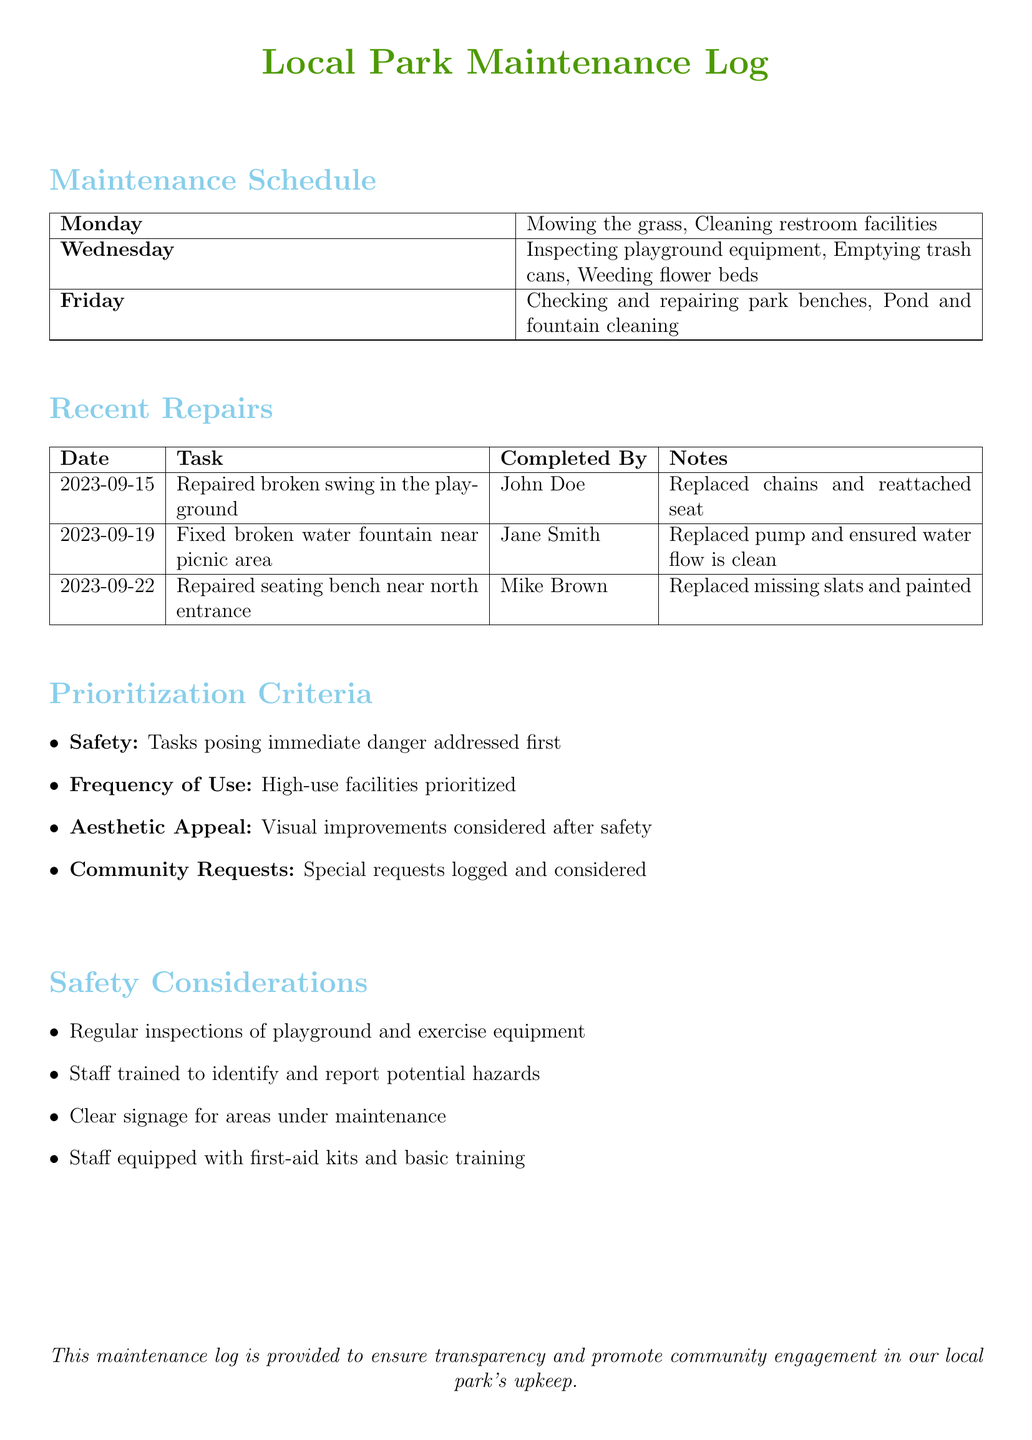What is the main task scheduled for Monday? The main tasks for Monday are mowing the grass and cleaning restroom facilities.
Answer: Mowing the grass, Cleaning restroom facilities Which facility was repaired on September 19? On September 19, the broken water fountain near the picnic area was fixed.
Answer: Water fountain near picnic area Who completed the swing repair task? The person who completed the swing repair task is mentioned in the recent repairs section.
Answer: John Doe What is the first priority in the prioritization criteria? The prioritization criteria start with safety, indicating the highest priority.
Answer: Safety How many tasks are scheduled for Wednesday? By counting the activities listed, we can determine how many tasks are scheduled.
Answer: Three What type of signage is mentioned for areas under maintenance? The safety considerations list a specific type of signage that is needed.
Answer: Clear signage What is the purpose of this maintenance log? The purpose is stated at the bottom of the document and emphasizes community engagement.
Answer: Transparency and promote community engagement 